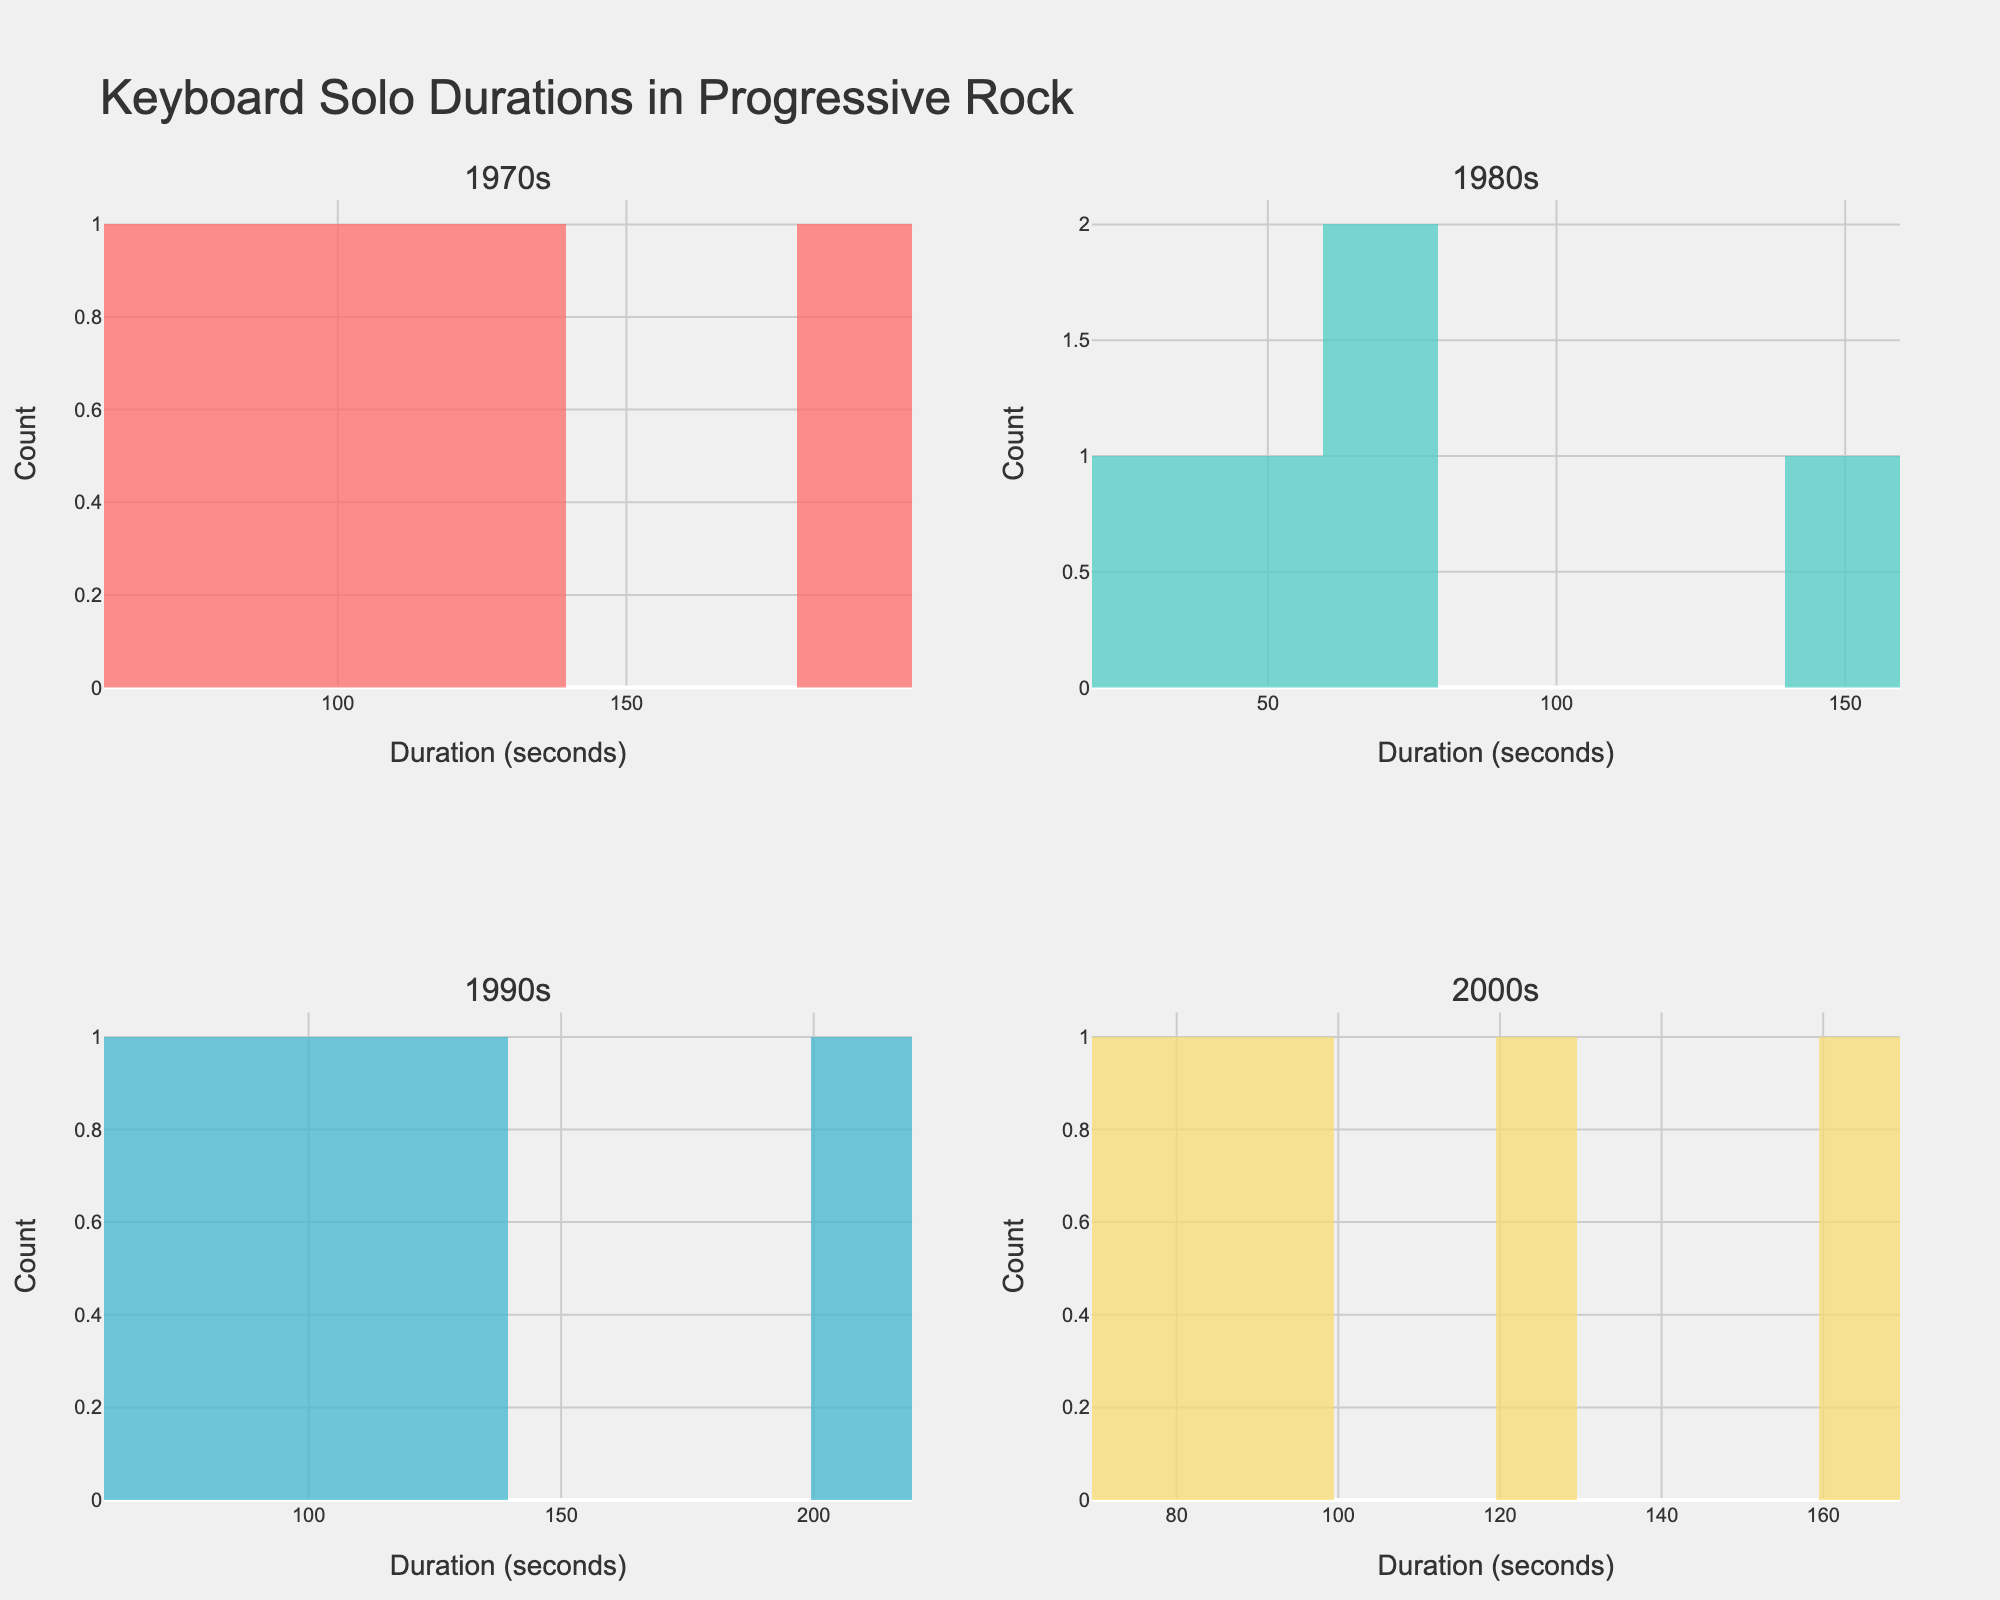What is the title of the figure? The title of the figure is displayed at the top center of the plot. It reads "Keyboard Solo Durations in Progressive Rock".
Answer: Keyboard Solo Durations in Progressive Rock Which era has the highest count of keyboard solos in the 30-45 seconds range? Look at each subplot and identify the count of keyboard solos in the 30-45 seconds duration range. The 1980s has a bar with this range and the highest count.
Answer: 1980s How many keyboard solos are there in the 60-75 seconds range in the 1990s? Locate the 60-75 seconds duration range in the 1990s subplot and count the number of solos. There is one bar representing one solo in this range.
Answer: 1 Which era has the shortest keyboard solo duration in the data? Examine each subplot for the minimum value on the x-axis that has a bar. The shortest duration bar is in the 1980s, which is 30 seconds.
Answer: 1980s Are there more solos in the 90-105 seconds range in the 1970s or the 2000s? Compare the 90-105 seconds range in the subplots for 1970s and 2000s. The 1970s subplot has one bar at 90 seconds and one at 105 seconds, giving a count of 2, while the 2000s have one bar at 95 seconds giving a count of 1.
Answer: 1970s What is the range of durations for keyboard solos in the 2000s? Identify the smallest and largest x-axis values with bars in the 2000s subplot. The durations range from 75 seconds to 165 seconds.
Answer: 75 to 165 seconds Which era features the highest peak in terms of the count of solos in a single duration bin? Find the tallest bar in each subplot, and the era with the highest peak overall. The 1970s have the highest single count peak with one bin having 2 solos.
Answer: 1970s How does the distribution of keyboard solos in the 1990s differ from that of the 1980s? Look at the shape and spread of the bars in both the 1990s and 1980s subplots. The 1990s shows a wider spread from 60 to 210 seconds, while the 1980s has solos mostly clustered between 30 and 150 seconds.
Answer: The 1990s has a wider spread of durations What can you say about the variety in keyboard solo durations from the 1970s to the 2000s? Compare the subplots for each decade, assess the spread and variety in the durations. The 1970s and 2000s both show solos with more varied durations while other eras show clustering around certain durations.
Answer: The 1970s and 1990s show more variety 